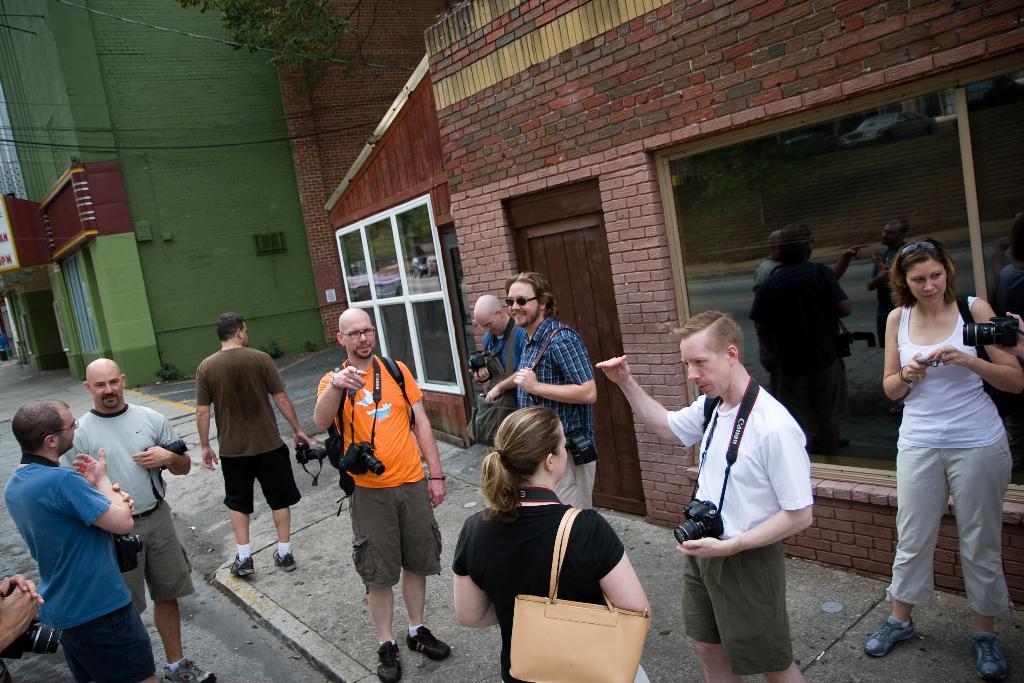Describe this image in one or two sentences. In this image there are buildings truncated towards the top of the image, there are windows, there is the door, there is the wall, there is a board truncated towards the right of the image, there are group of persons, there are windows truncated towards the right of the image, there are persons holding objects, there is a person truncated towards the right of the image, there is a person truncated towards the left of the image, there are plants, there is the road, there are persons truncated towards the bottom of the image. 